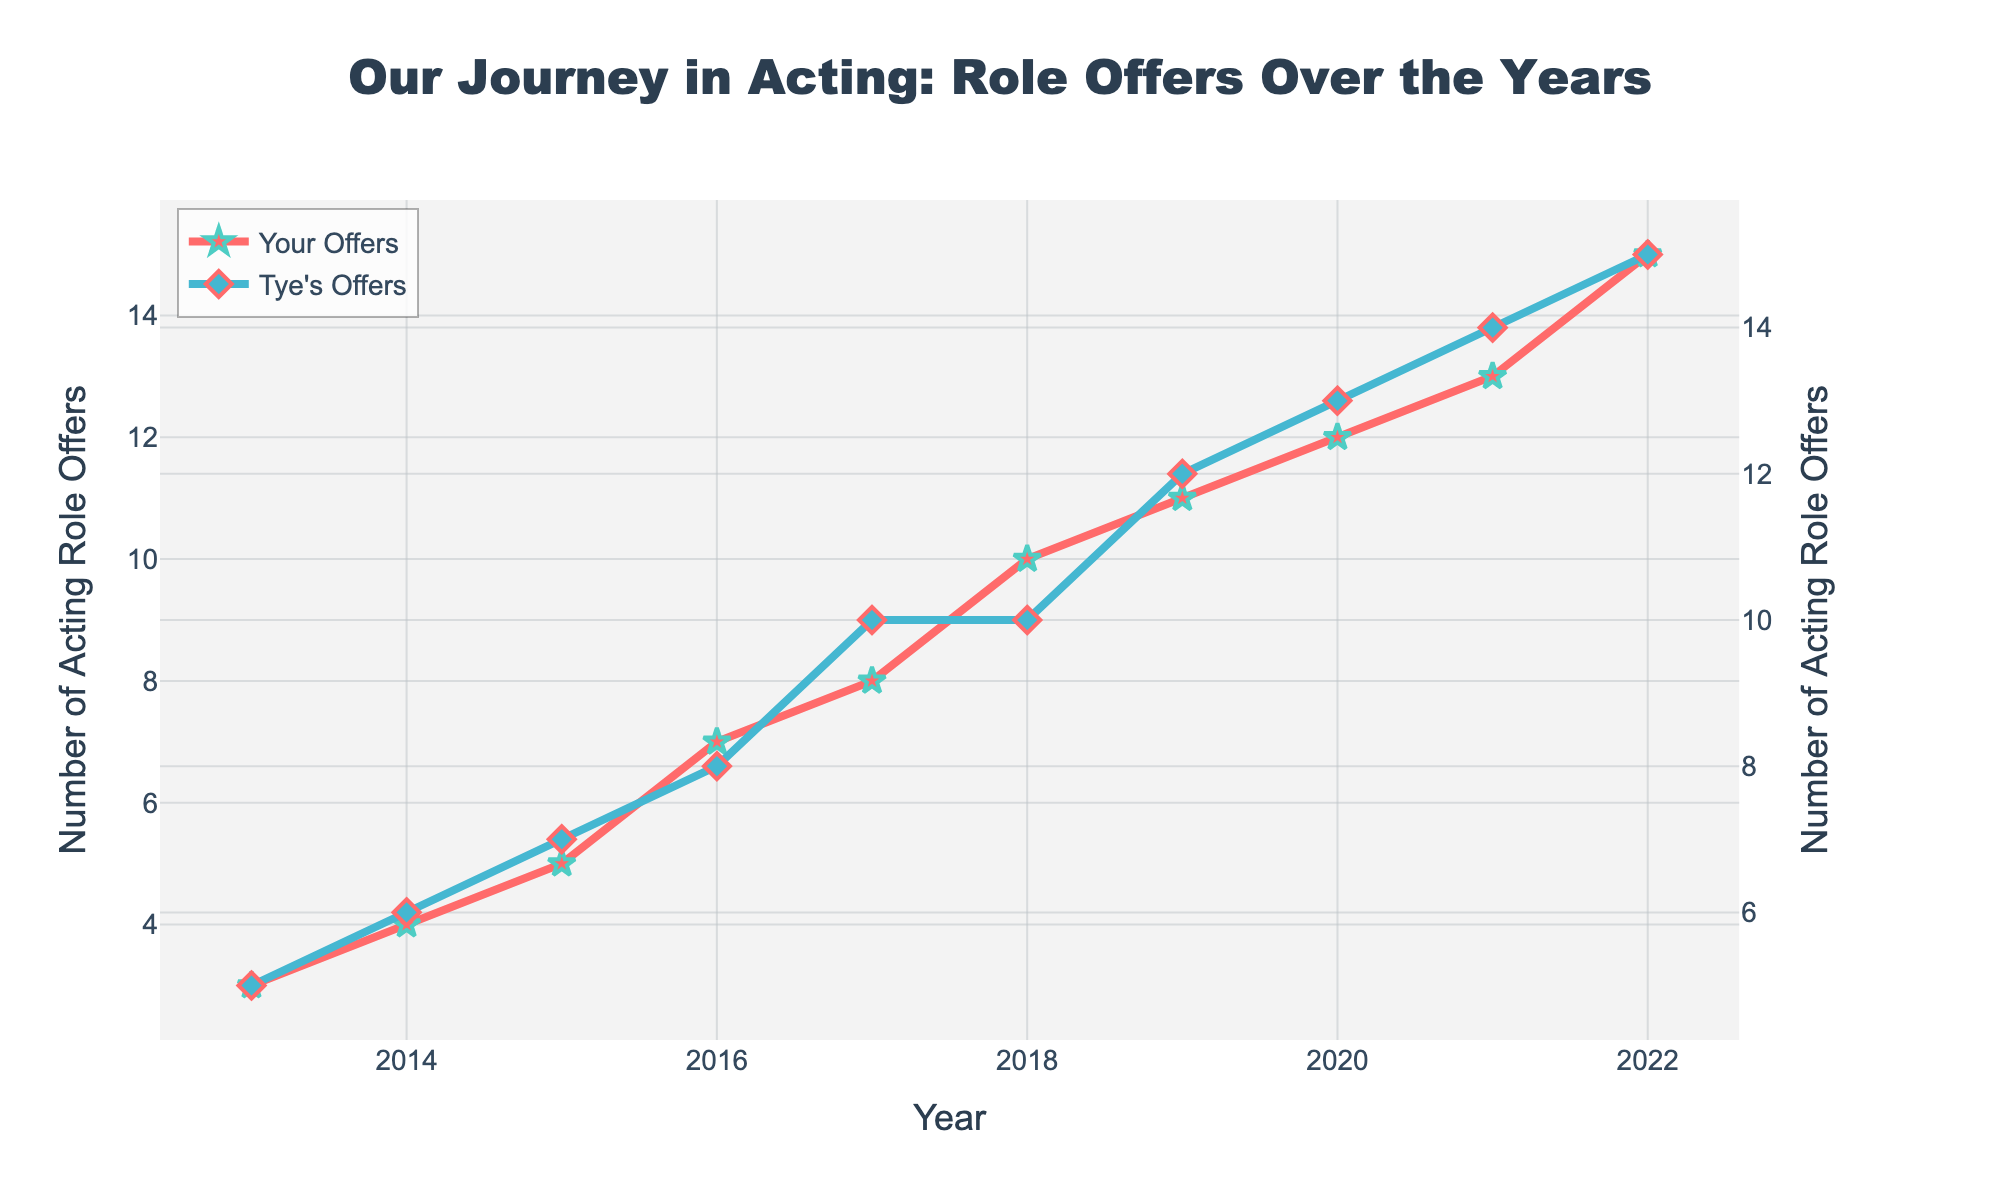What is the title of the figure? The title of the figure is positioned at the top center and is meant to provide a summary of the visualized data. By reading the text there, it clearly states the context of the plot.
Answer: Our Journey in Acting: Role Offers Over the Years What do the markers on the red line represent? The red line with star markers represents the number of acting role offers received by you each year. The star markers make it easier to identify the data points for your offers.
Answer: Your acting role offers How many role offers did Tye Sheridan receive in 2019? You look at the blue line at the year 2019 on the x-axis and then find the corresponding y-value. The blue line's marker for 2019 intersects the y-axis at 12.
Answer: 12 Which year did both you and Tye receive the same number of offers? To answer this, you need to find the year where both lines intersect. By inspecting the figure, we see that the red and blue lines meet at the year 2022.
Answer: 2022 In which year did you see the highest growth in the number of acting role offers? To determine this, calculate the year-over-year difference for your offers and identify the largest increase. From 2016 to 2017, the number of your offers increased from 7 to 8, which is an increase of 1. This is the highest annual growth based on the data points in the figure.
Answer: 2016-2017 What is the total number of role offers you received from 2013 to 2022? Sum the y-values of the red line markers from 2013 to 2022. The total number is 3+4+5+7+8+10+11+12+13+15 = 88.
Answer: 88 Did Tye Sheridan ever receive fewer role offers than you in any year? By visually comparing the two lines for each year, we can see that Tye's line (blue) is never below your line (red) at any point throughout the period. Hence, Tye always received as many or more offers each year.
Answer: No In which year did both you and Tye see no change in the number of offers compared to the previous year? Look for points where both lines are horizontal, indicating no change from the previous year. From 2017 to 2018, Tye's offers remained the same at 10, and your offers also increased by 2 which is consistent with the annual increasing trend.
Answer: Trick question, only Tye in 2017-2018 Which year saw the largest difference between the number of offers received by you and Tye? Calculate the absolute difference between the two lines for each year and identify the largest one. The largest difference appears in 2013, where Tye had 5 offers while you had 3 offers, making the difference 5 - 3 = 2.
Answer: 2013 How did the number of role offers received by Tye between 2016 and 2017 change? Check the y-values for Tye's offers for the years 2016 and 2017. The number of offers increased from 8 in 2016 to 10 in 2017, which is an increase of 2.
Answer: Increased by 2 